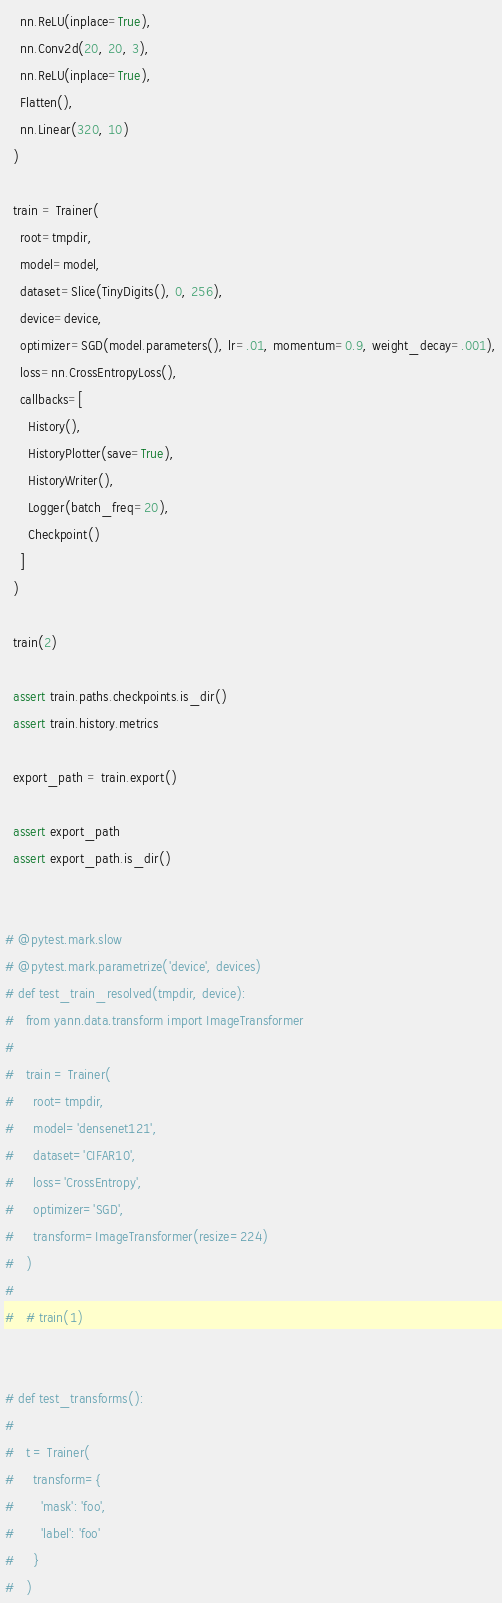<code> <loc_0><loc_0><loc_500><loc_500><_Python_>    nn.ReLU(inplace=True),
    nn.Conv2d(20, 20, 3),
    nn.ReLU(inplace=True),
    Flatten(),
    nn.Linear(320, 10)
  )

  train = Trainer(
    root=tmpdir,
    model=model,
    dataset=Slice(TinyDigits(), 0, 256),
    device=device,
    optimizer=SGD(model.parameters(), lr=.01, momentum=0.9, weight_decay=.001),
    loss=nn.CrossEntropyLoss(),
    callbacks=[
      History(),
      HistoryPlotter(save=True),
      HistoryWriter(),
      Logger(batch_freq=20),
      Checkpoint()
    ]
  )

  train(2)

  assert train.paths.checkpoints.is_dir()
  assert train.history.metrics

  export_path = train.export()

  assert export_path
  assert export_path.is_dir()


# @pytest.mark.slow
# @pytest.mark.parametrize('device', devices)
# def test_train_resolved(tmpdir, device):
#   from yann.data.transform import ImageTransformer
#
#   train = Trainer(
#     root=tmpdir,
#     model='densenet121',
#     dataset='CIFAR10',
#     loss='CrossEntropy',
#     optimizer='SGD',
#     transform=ImageTransformer(resize=224)
#   )
#
#   # train(1)


# def test_transforms():
#
#   t = Trainer(
#     transform={
#       'mask': 'foo',
#       'label': 'foo'
#     }
#   )</code> 